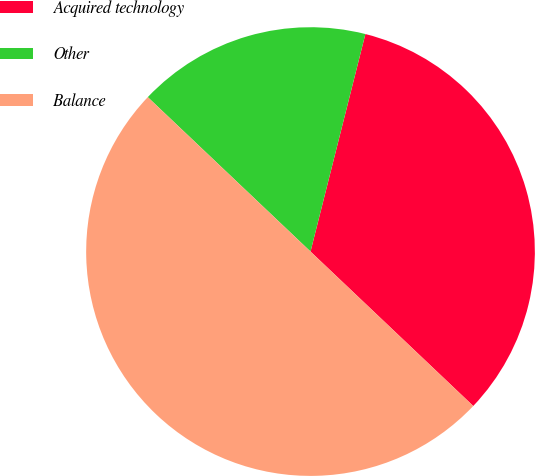Convert chart to OTSL. <chart><loc_0><loc_0><loc_500><loc_500><pie_chart><fcel>Acquired technology<fcel>Other<fcel>Balance<nl><fcel>33.15%<fcel>16.85%<fcel>50.0%<nl></chart> 